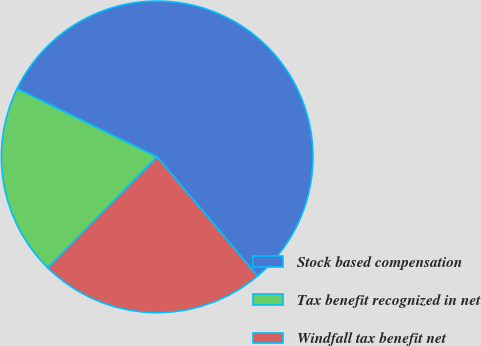Convert chart to OTSL. <chart><loc_0><loc_0><loc_500><loc_500><pie_chart><fcel>Stock based compensation<fcel>Tax benefit recognized in net<fcel>Windfall tax benefit net<nl><fcel>56.65%<fcel>19.84%<fcel>23.52%<nl></chart> 